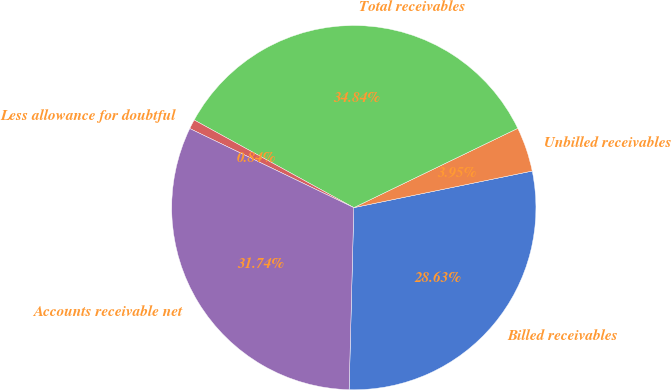<chart> <loc_0><loc_0><loc_500><loc_500><pie_chart><fcel>Billed receivables<fcel>Unbilled receivables<fcel>Total receivables<fcel>Less allowance for doubtful<fcel>Accounts receivable net<nl><fcel>28.63%<fcel>3.95%<fcel>34.84%<fcel>0.84%<fcel>31.74%<nl></chart> 